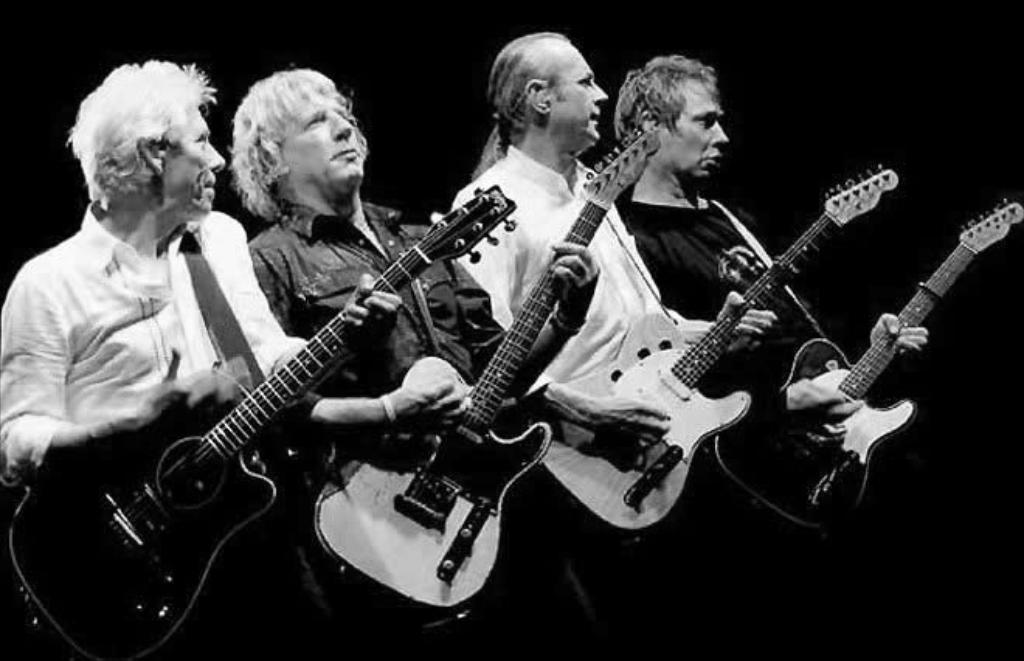How many people are in the image? There are four persons in the image. What are the four persons doing in the image? All four persons are playing the guitar. Can you describe the clothing of the first person? One person is wearing a shirt. And the clothing of the second person? Another person is wearing a T-shirt. What type of screw can be seen holding the cake together in the image? There is no cake or screw present in the image; it features four persons playing the guitar. How is the glue being used by the persons in the image? There is no glue present in the image; the persons are playing the guitar. 